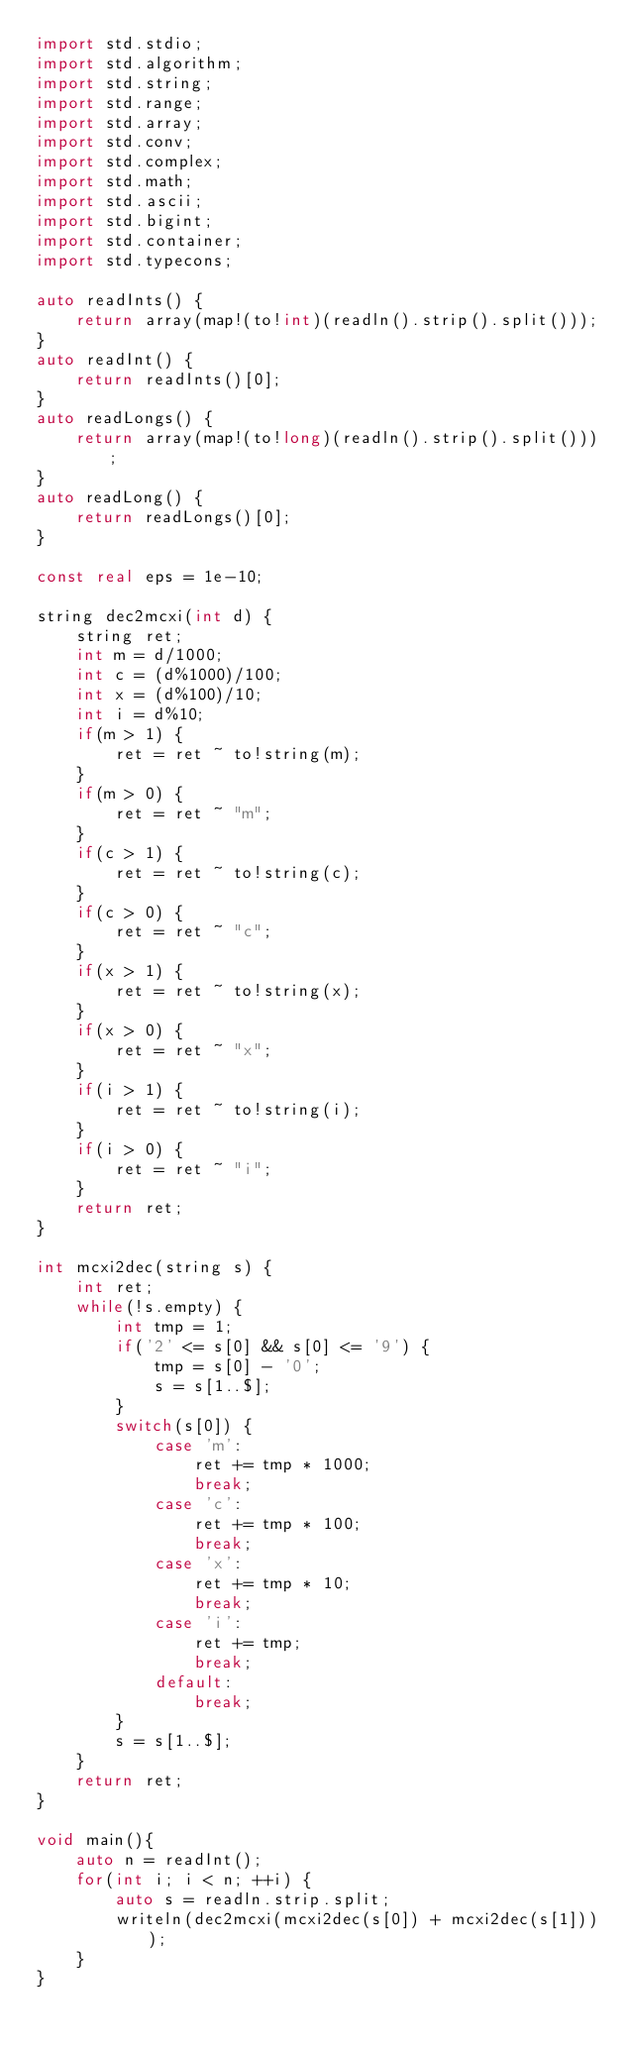<code> <loc_0><loc_0><loc_500><loc_500><_D_>import std.stdio;
import std.algorithm;
import std.string;
import std.range;
import std.array;
import std.conv;
import std.complex;
import std.math;
import std.ascii;
import std.bigint;
import std.container;
import std.typecons;

auto readInts() {
	return array(map!(to!int)(readln().strip().split()));
}
auto readInt() {
	return readInts()[0];
}
auto readLongs() {
	return array(map!(to!long)(readln().strip().split()));
}
auto readLong() {
	return readLongs()[0];
}

const real eps = 1e-10;

string dec2mcxi(int d) {
	string ret;
	int m = d/1000;
	int c = (d%1000)/100;
	int x = (d%100)/10;
	int i = d%10;
	if(m > 1) {
		ret = ret ~ to!string(m);
	}
	if(m > 0) {
		ret = ret ~ "m";
	}
	if(c > 1) {
		ret = ret ~ to!string(c);
	}
	if(c > 0) { 
		ret = ret ~ "c";
	}
	if(x > 1) {
		ret = ret ~ to!string(x);
	}
	if(x > 0) { 
		ret = ret ~ "x";
	}
	if(i > 1) {
		ret = ret ~ to!string(i);
	}
	if(i > 0) { 
		ret = ret ~ "i";
	}
	return ret;
}

int mcxi2dec(string s) {
	int ret;
	while(!s.empty) {
		int tmp = 1;
		if('2' <= s[0] && s[0] <= '9') {
			tmp = s[0] - '0';
			s = s[1..$];
		}
		switch(s[0]) {
			case 'm':
				ret += tmp * 1000;
				break;
			case 'c':
				ret += tmp * 100;
				break;
			case 'x':
				ret += tmp * 10;
				break;
			case 'i':
				ret += tmp;
				break;
			default:
				break;
		}
		s = s[1..$];
	}
	return ret;
}

void main(){
	auto n = readInt();
	for(int i; i < n; ++i) {
		auto s = readln.strip.split;
		writeln(dec2mcxi(mcxi2dec(s[0]) + mcxi2dec(s[1])));
	}
}</code> 